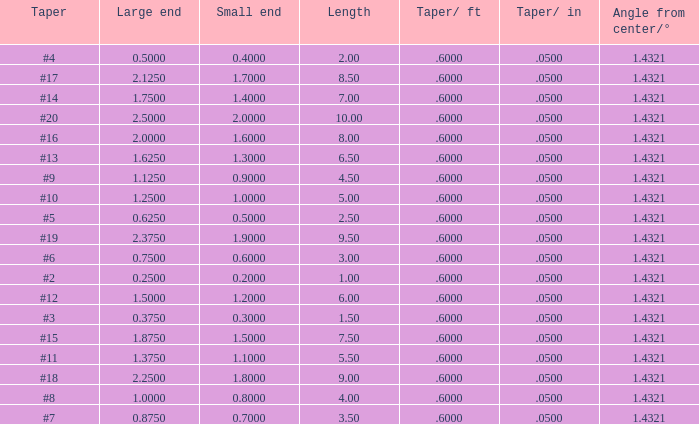Which Angle from center/° has a Taper/ft smaller than 0.6000000000000001? 19.0. 